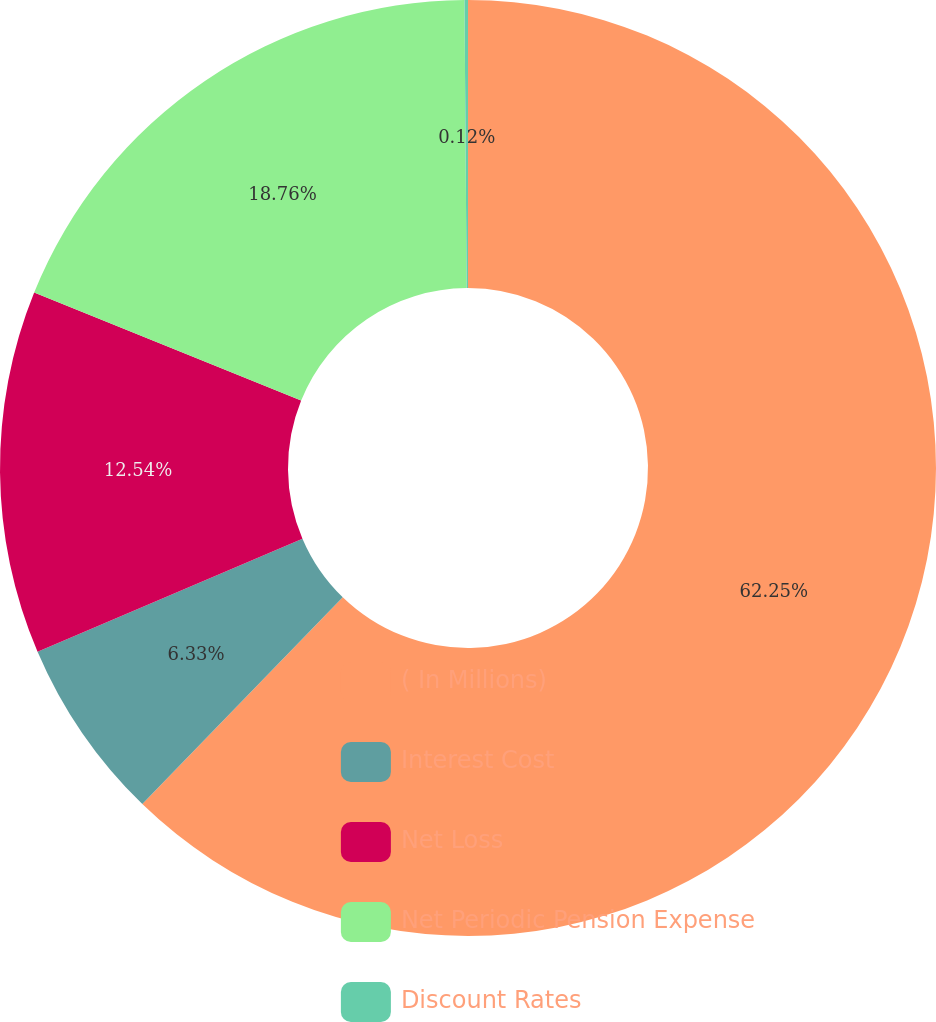<chart> <loc_0><loc_0><loc_500><loc_500><pie_chart><fcel>( In Millions)<fcel>Interest Cost<fcel>Net Loss<fcel>Net Periodic Pension Expense<fcel>Discount Rates<nl><fcel>62.25%<fcel>6.33%<fcel>12.54%<fcel>18.76%<fcel>0.12%<nl></chart> 